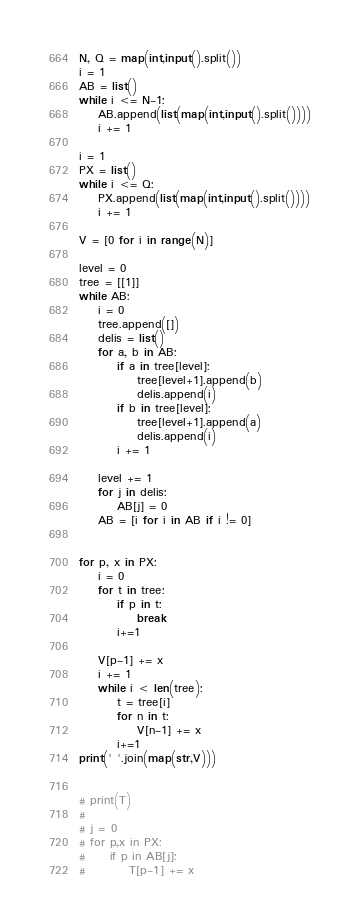<code> <loc_0><loc_0><loc_500><loc_500><_Python_>N, Q = map(int,input().split())
i = 1
AB = list()
while i <= N-1:
    AB.append(list(map(int,input().split())))
    i += 1

i = 1
PX = list()
while i <= Q:
    PX.append(list(map(int,input().split())))
    i += 1

V = [0 for i in range(N)]

level = 0
tree = [[1]]
while AB:
    i = 0
    tree.append([])
    delis = list()
    for a, b in AB:
        if a in tree[level]:
            tree[level+1].append(b)
            delis.append(i)
        if b in tree[level]:
            tree[level+1].append(a)
            delis.append(i)
        i += 1

    level += 1
    for j in delis:
        AB[j] = 0
    AB = [i for i in AB if i != 0]


for p, x in PX:
    i = 0
    for t in tree:
        if p in t:
            break
        i+=1

    V[p-1] += x
    i += 1
    while i < len(tree):
        t = tree[i]
        for n in t:
            V[n-1] += x
        i+=1
print(' '.join(map(str,V)))


# print(T)
#
# j = 0
# for p,x in PX:
#     if p in AB[j]:
#         T[p-1] += x
</code> 